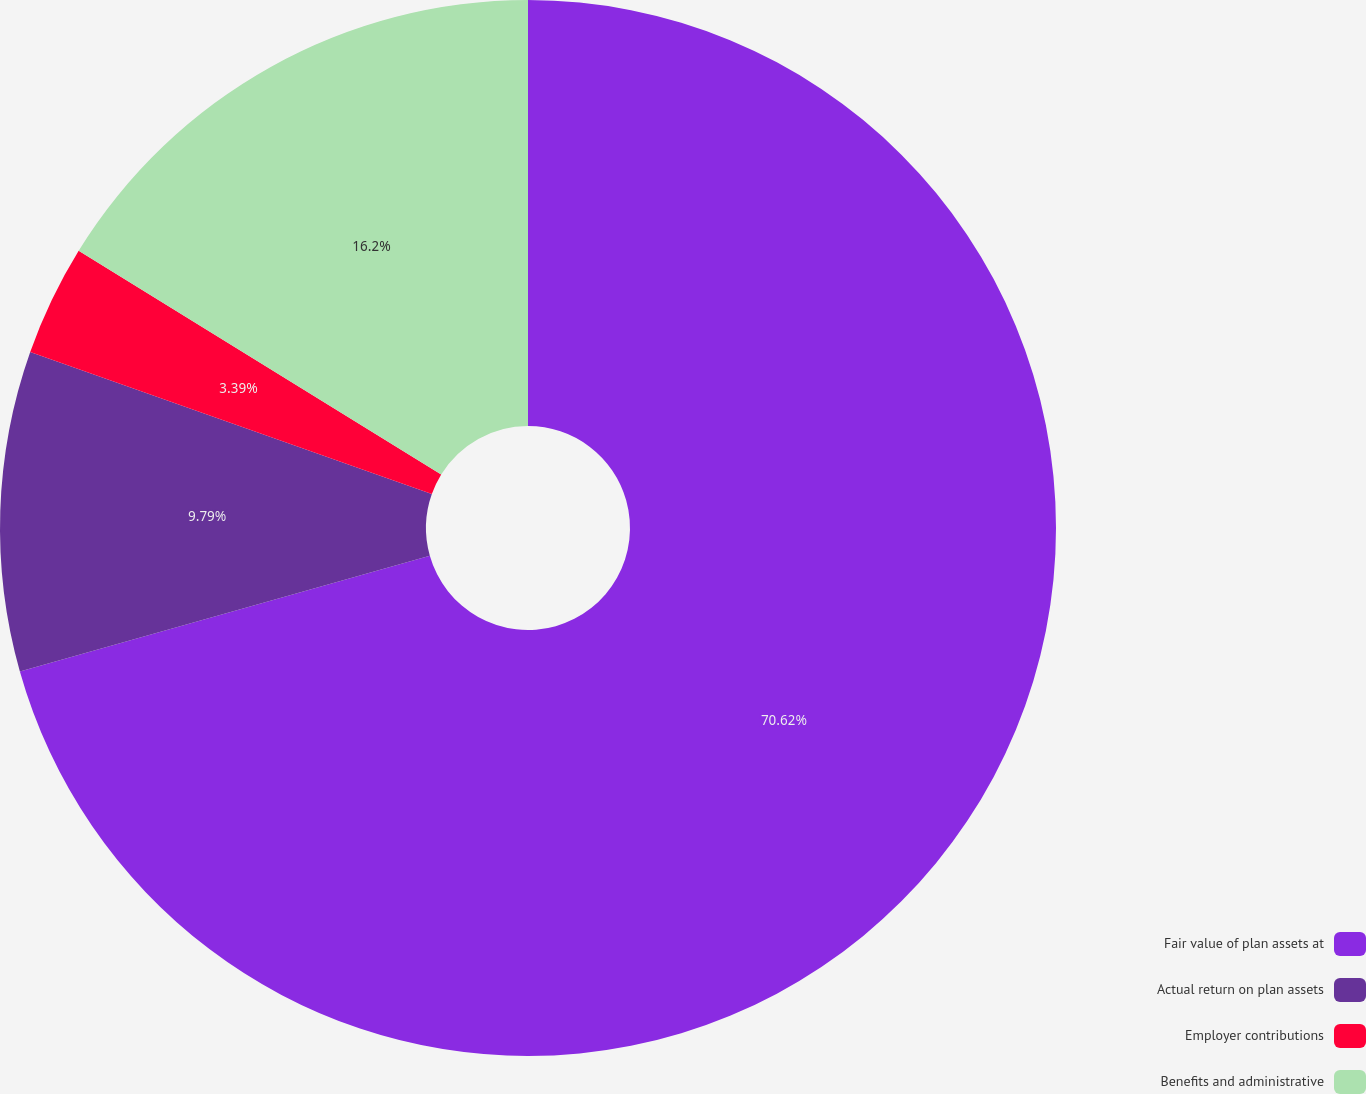<chart> <loc_0><loc_0><loc_500><loc_500><pie_chart><fcel>Fair value of plan assets at<fcel>Actual return on plan assets<fcel>Employer contributions<fcel>Benefits and administrative<nl><fcel>70.62%<fcel>9.79%<fcel>3.39%<fcel>16.2%<nl></chart> 